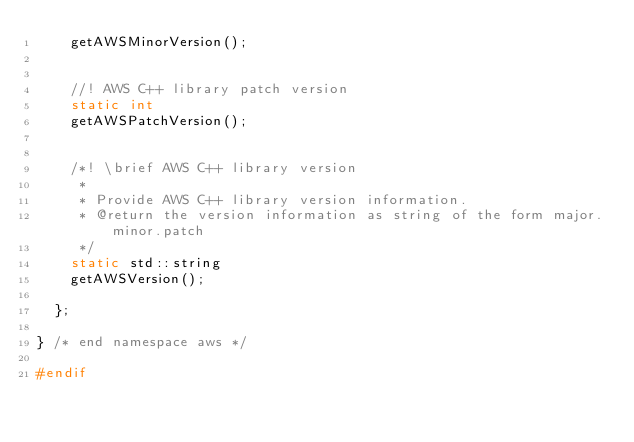<code> <loc_0><loc_0><loc_500><loc_500><_C_>    getAWSMinorVersion();


    //! AWS C++ library patch version
    static int
    getAWSPatchVersion();


    /*! \brief AWS C++ library version
     *
     * Provide AWS C++ library version information.
     * @return the version information as string of the form major.minor.patch
     */
    static std::string
    getAWSVersion();

  };

} /* end namespace aws */

#endif
</code> 